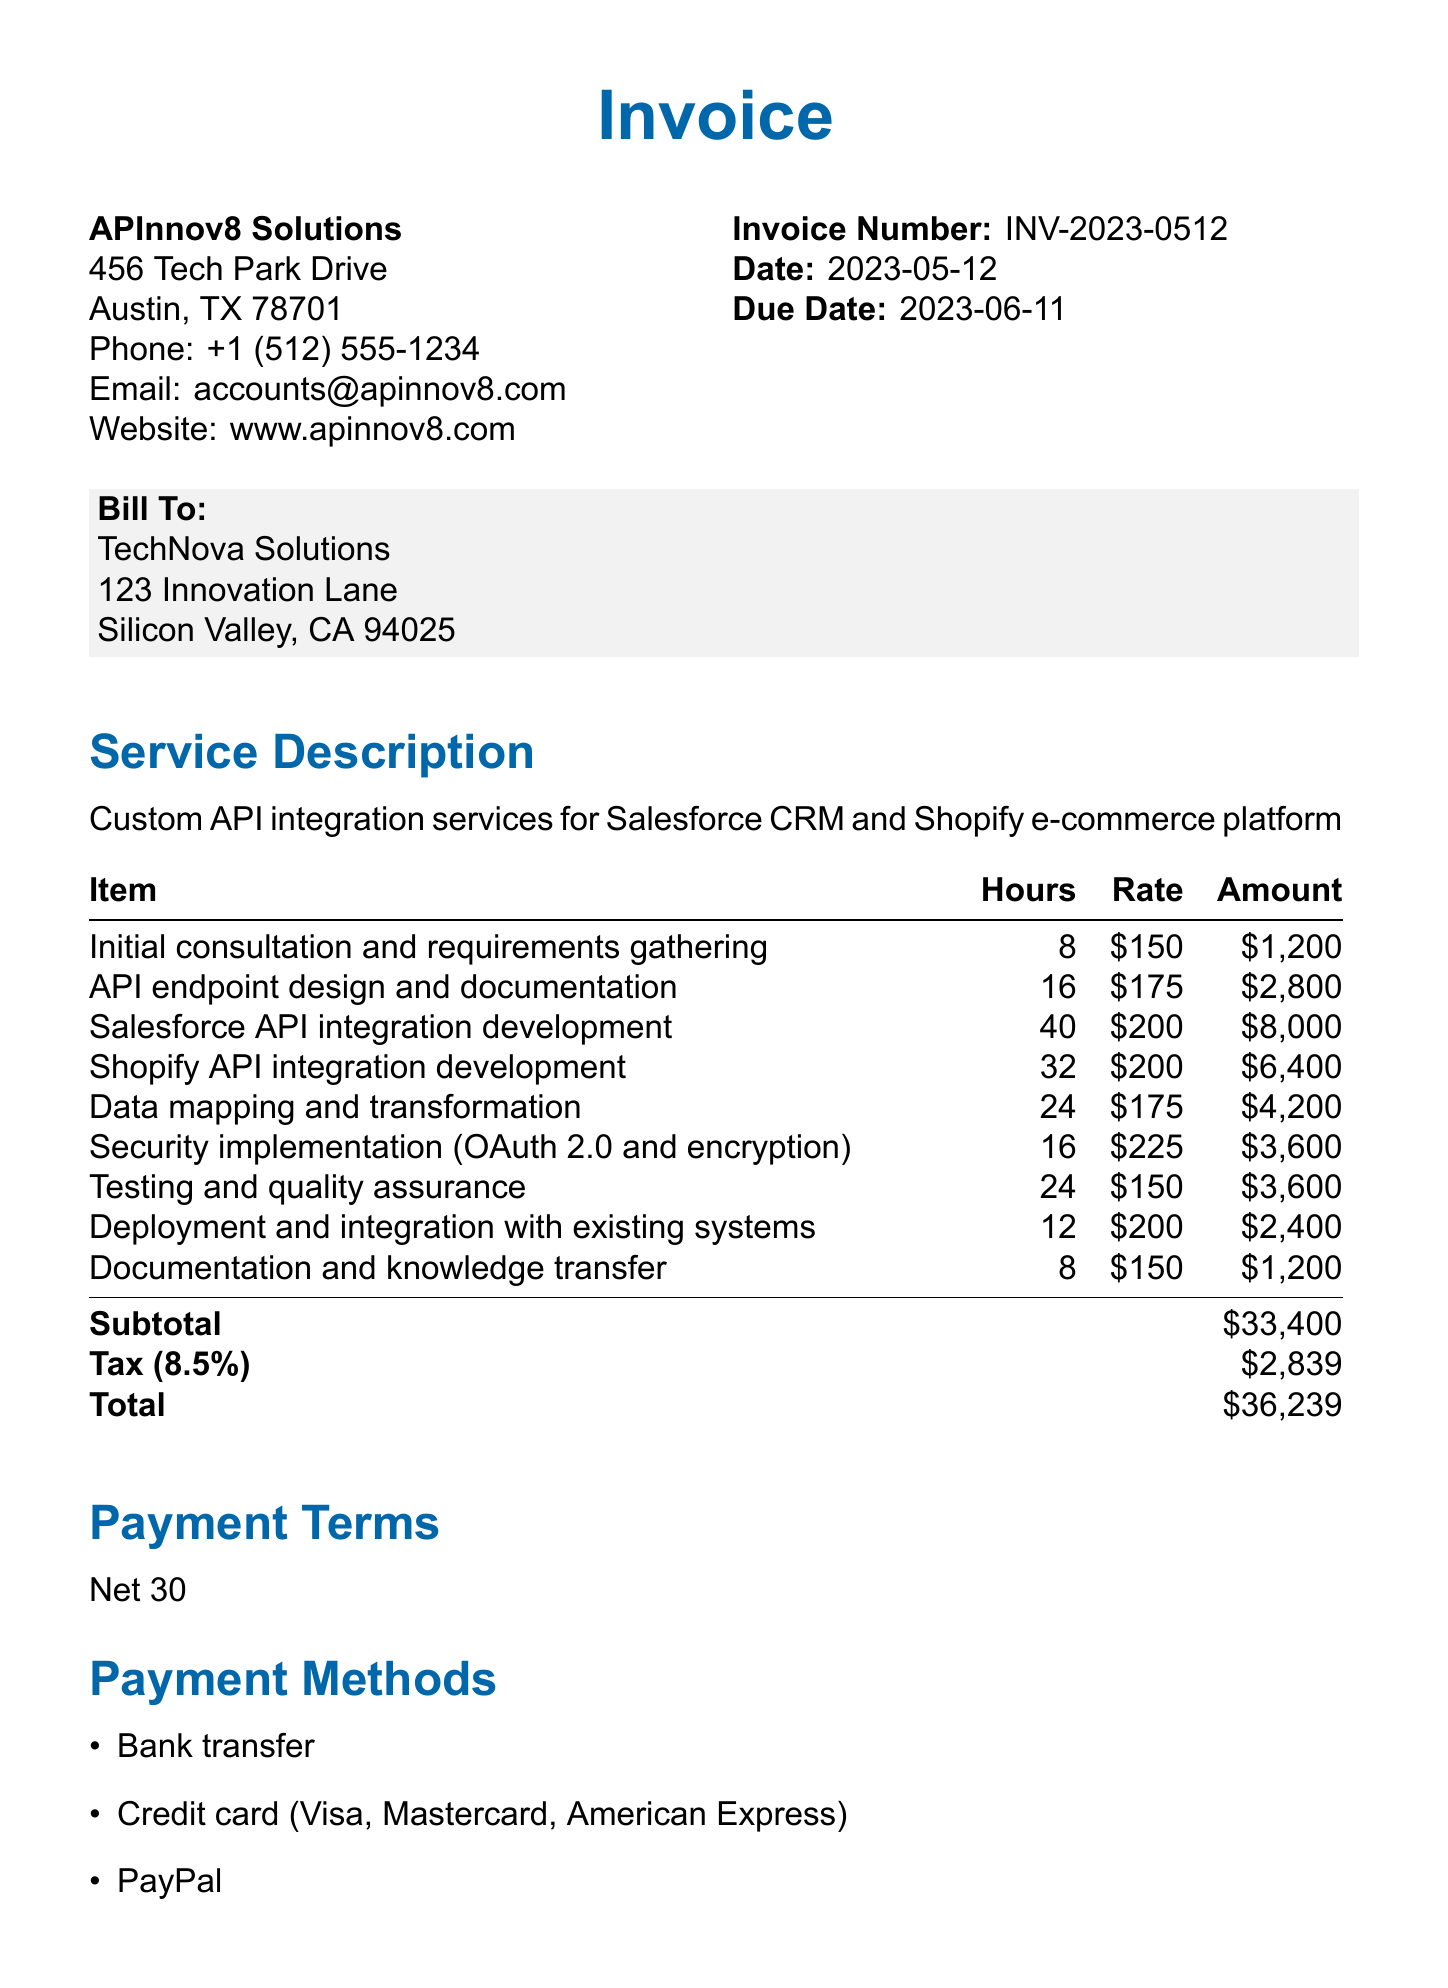What is the invoice number? The invoice number is specified in the document under 'Invoice Number'.
Answer: INV-2023-0512 What is the due date for the invoice? The due date is stated in the document under 'Due Date'.
Answer: 2023-06-11 Who is the client? The client name is mentioned in the 'Bill To' section of the document.
Answer: TechNova Solutions What is the subtotal amount? The subtotal is listed in the itemized costs section of the document.
Answer: $33,400 How many hours were spent on Salesforce API integration development? The hours for Salesforce API integration development are provided in the itemized costs.
Answer: 40 What is the tax rate applied? The tax rate is specifically mentioned in the additional details section.
Answer: 0.085 What is the total amount due? The total amount is calculated and listed at the end of the itemized costs section.
Answer: $36,239 What payment methods are accepted? The payment methods are listed in the 'Payment Methods' section.
Answer: Bank transfer, Credit card (Visa, Mastercard, American Express), PayPal Are ongoing support and maintenance included in this invoice? This information is provided in the 'Notes' section of the document.
Answer: No 